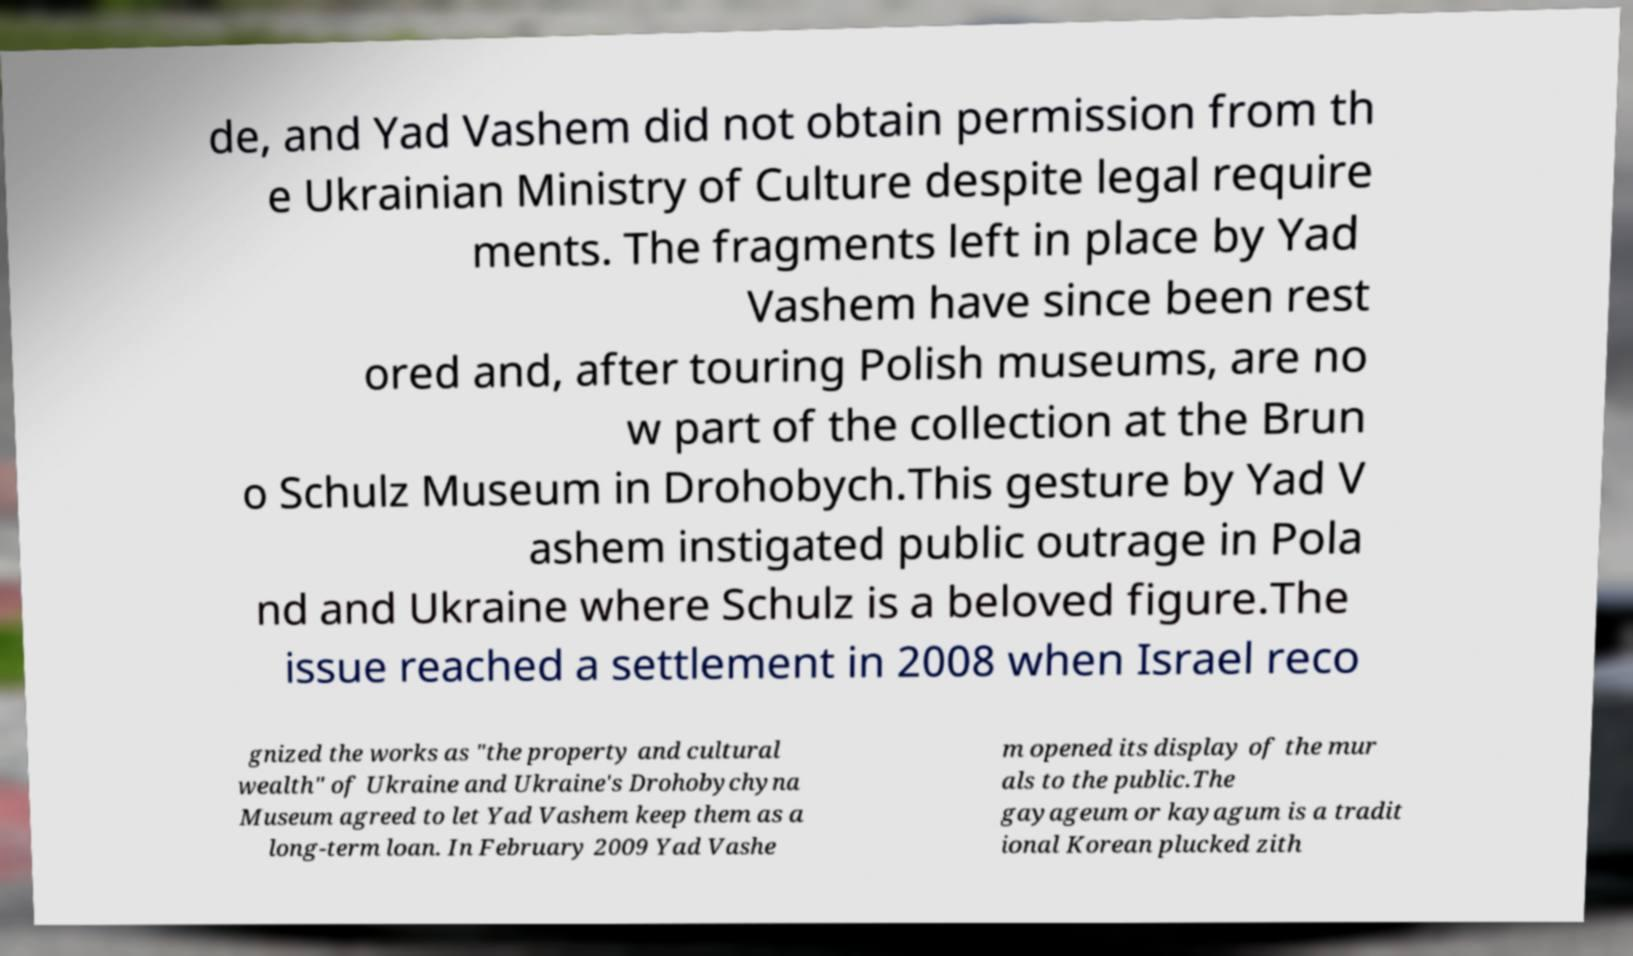Could you assist in decoding the text presented in this image and type it out clearly? de, and Yad Vashem did not obtain permission from th e Ukrainian Ministry of Culture despite legal require ments. The fragments left in place by Yad Vashem have since been rest ored and, after touring Polish museums, are no w part of the collection at the Brun o Schulz Museum in Drohobych.This gesture by Yad V ashem instigated public outrage in Pola nd and Ukraine where Schulz is a beloved figure.The issue reached a settlement in 2008 when Israel reco gnized the works as "the property and cultural wealth" of Ukraine and Ukraine's Drohobychyna Museum agreed to let Yad Vashem keep them as a long-term loan. In February 2009 Yad Vashe m opened its display of the mur als to the public.The gayageum or kayagum is a tradit ional Korean plucked zith 